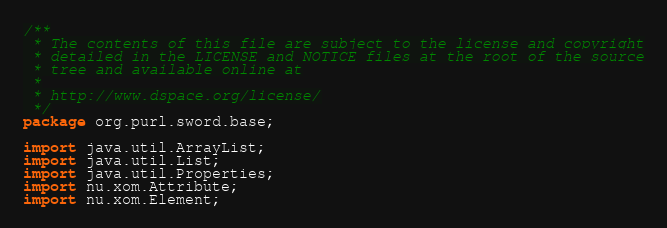Convert code to text. <code><loc_0><loc_0><loc_500><loc_500><_Java_>/**
 * The contents of this file are subject to the license and copyright
 * detailed in the LICENSE and NOTICE files at the root of the source
 * tree and available online at
 *
 * http://www.dspace.org/license/
 */
package org.purl.sword.base;

import java.util.ArrayList;
import java.util.List;
import java.util.Properties;
import nu.xom.Attribute;
import nu.xom.Element;
</code> 